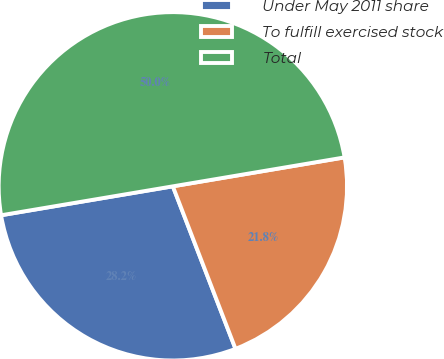<chart> <loc_0><loc_0><loc_500><loc_500><pie_chart><fcel>Under May 2011 share<fcel>To fulfill exercised stock<fcel>Total<nl><fcel>28.2%<fcel>21.8%<fcel>50.0%<nl></chart> 